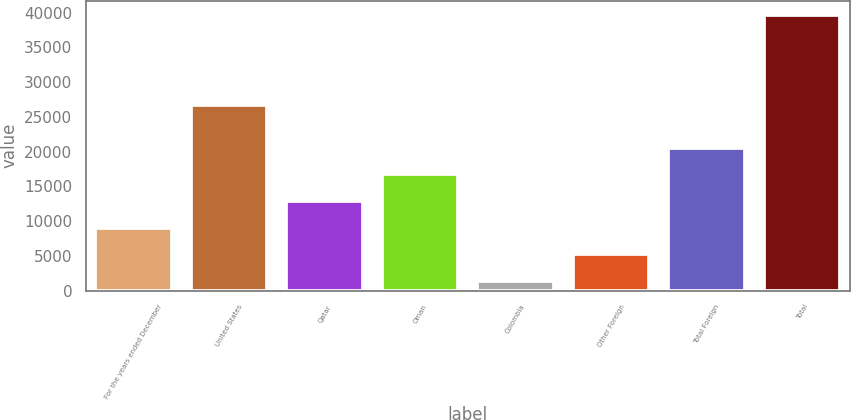<chart> <loc_0><loc_0><loc_500><loc_500><bar_chart><fcel>For the years ended December<fcel>United States<fcel>Qatar<fcel>Oman<fcel>Colombia<fcel>Other Foreign<fcel>Total Foreign<fcel>Total<nl><fcel>9062.8<fcel>26673<fcel>12896.2<fcel>16729.6<fcel>1396<fcel>5229.4<fcel>20563<fcel>39730<nl></chart> 